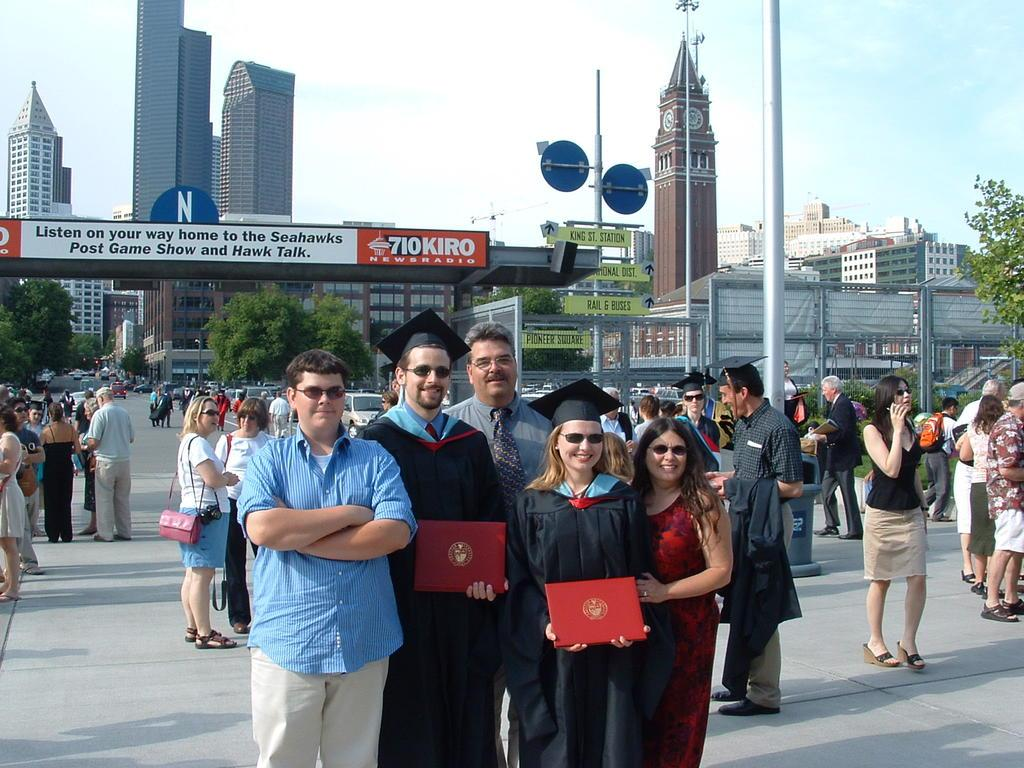<image>
Provide a brief description of the given image. Two graduates stand in front of a sign that advertises for the Seahawk's post game show. 